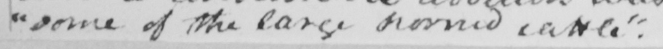Can you read and transcribe this handwriting? " some of the large horned cattle "  . 